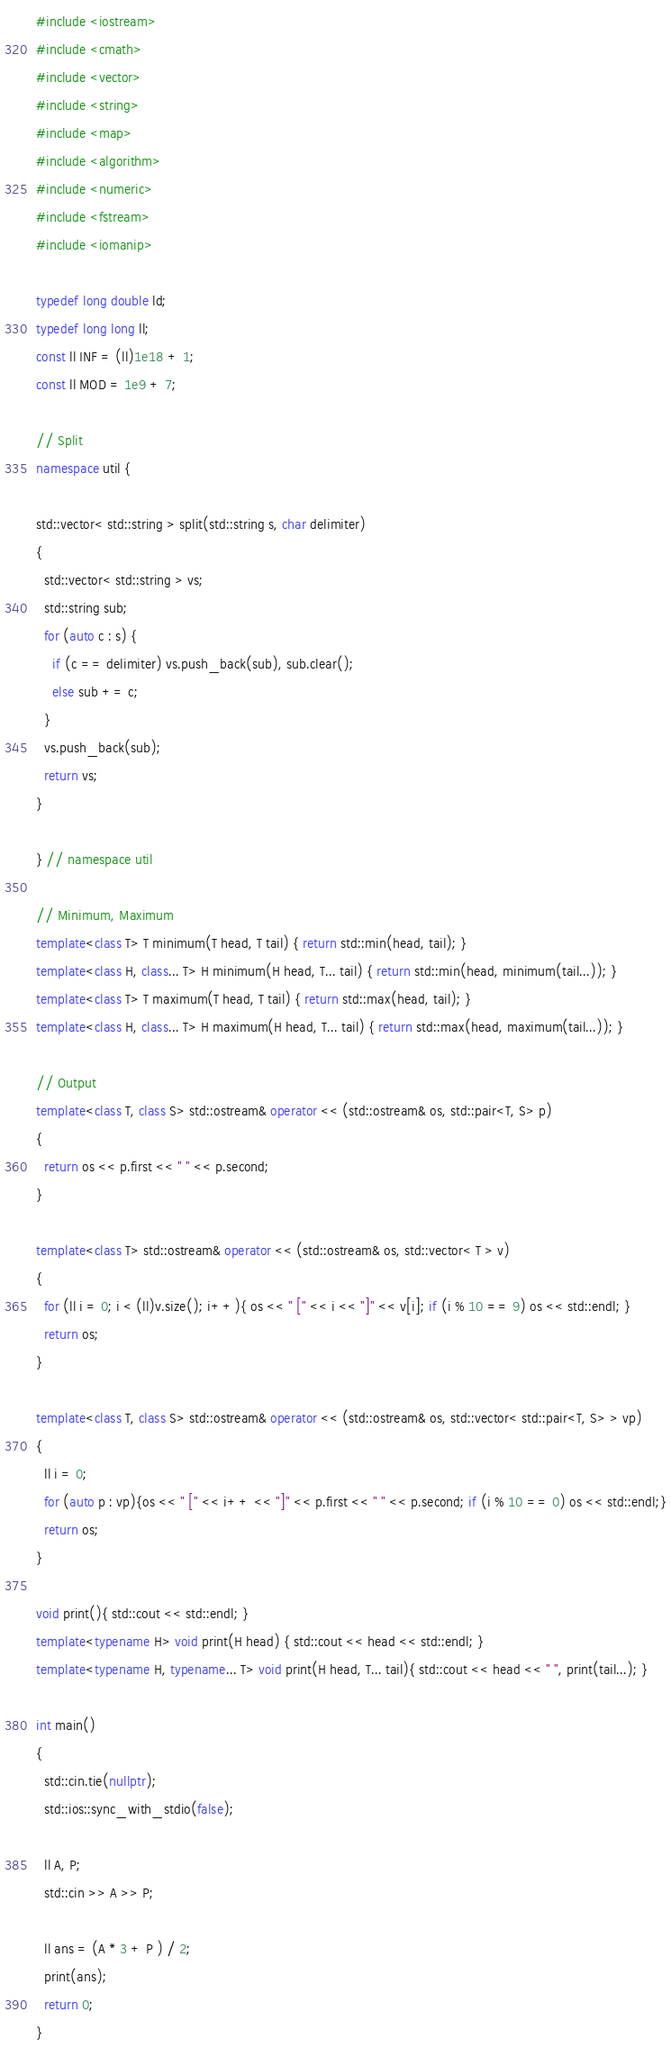<code> <loc_0><loc_0><loc_500><loc_500><_C++_>#include <iostream>
#include <cmath>
#include <vector>
#include <string>
#include <map>
#include <algorithm>
#include <numeric>
#include <fstream>
#include <iomanip>

typedef long double ld;
typedef long long ll;
const ll INF = (ll)1e18 + 1;
const ll MOD = 1e9 + 7;

// Split
namespace util {

std::vector< std::string > split(std::string s, char delimiter)
{
  std::vector< std::string > vs;
  std::string sub;
  for (auto c : s) {
    if (c == delimiter) vs.push_back(sub), sub.clear();
    else sub += c;
  }
  vs.push_back(sub);
  return vs;
}

} // namespace util

// Minimum, Maximum
template<class T> T minimum(T head, T tail) { return std::min(head, tail); }
template<class H, class... T> H minimum(H head, T... tail) { return std::min(head, minimum(tail...)); }
template<class T> T maximum(T head, T tail) { return std::max(head, tail); }
template<class H, class... T> H maximum(H head, T... tail) { return std::max(head, maximum(tail...)); }

// Output
template<class T, class S> std::ostream& operator << (std::ostream& os, std::pair<T, S> p)
{
  return os << p.first << " " << p.second;
}

template<class T> std::ostream& operator << (std::ostream& os, std::vector< T > v)
{
  for (ll i = 0; i < (ll)v.size(); i++){ os << " [" << i << "]" << v[i]; if (i % 10 == 9) os << std::endl; }
  return os;
}

template<class T, class S> std::ostream& operator << (std::ostream& os, std::vector< std::pair<T, S> > vp)
{
  ll i = 0;
  for (auto p : vp){os << " [" << i++ << "]" << p.first << " " << p.second; if (i % 10 == 0) os << std::endl;}
  return os;
}

void print(){ std::cout << std::endl; }
template<typename H> void print(H head) { std::cout << head << std::endl; }
template<typename H, typename... T> void print(H head, T... tail){ std::cout << head << " ", print(tail...); }

int main()
{
  std::cin.tie(nullptr);
  std::ios::sync_with_stdio(false);

  ll A, P;
  std::cin >> A >> P;

  ll ans = (A * 3 + P ) / 2;
  print(ans);
  return 0;
}
</code> 